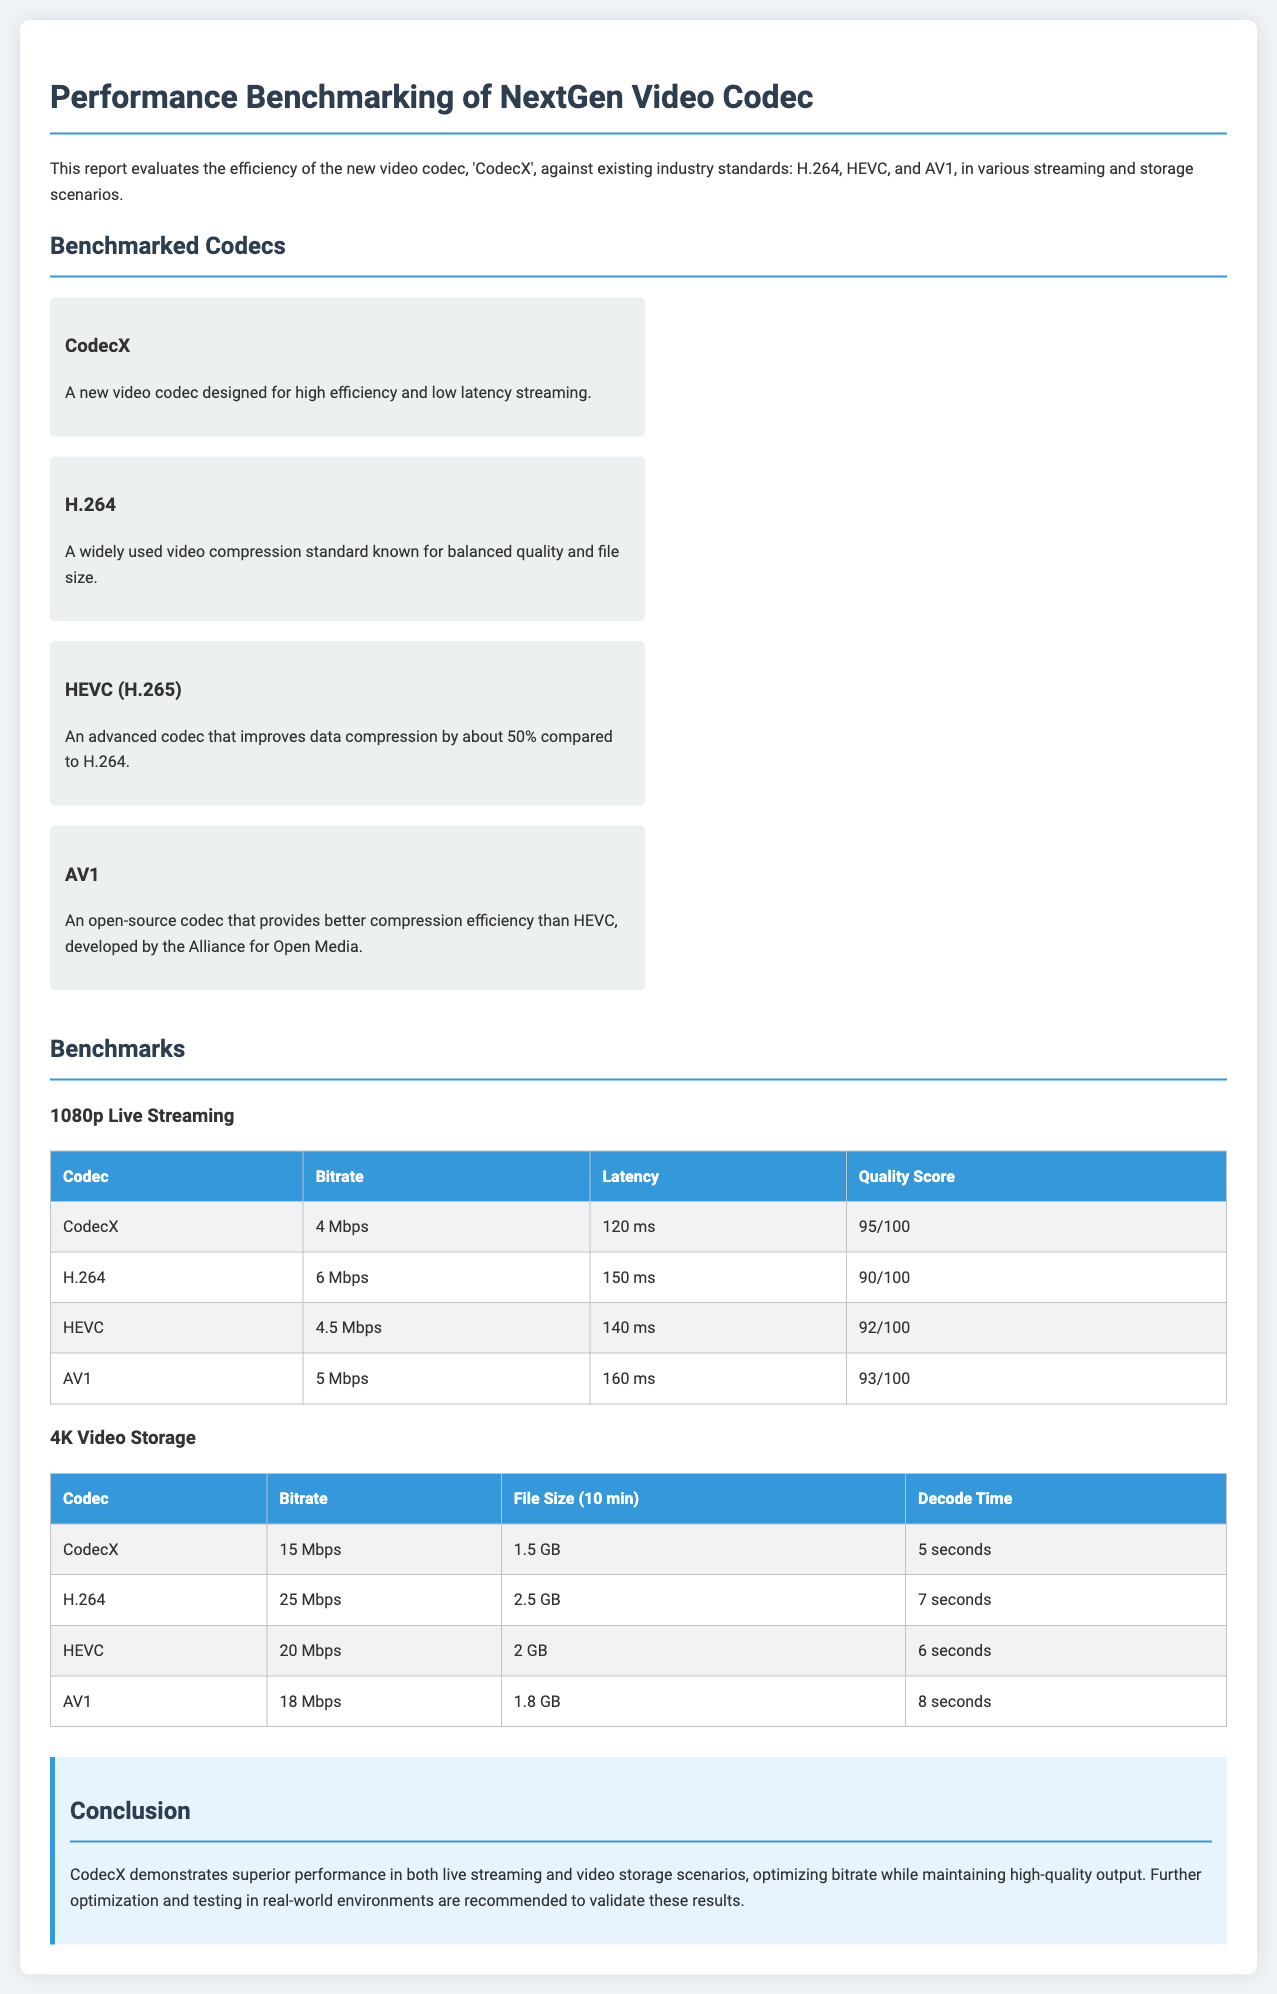What is the title of the report? The title of the report is prominently displayed at the top of the document.
Answer: Performance Benchmarking of NextGen Video Codec Which codec has the lowest bitrate in 1080p live streaming? The table provides the bitrate values for each codec in the specified scenario, highlighting CodecX as the lowest.
Answer: CodecX What is the quality score of H.264? The quality score for H.264 is explicitly mentioned in the benchmark table for live streaming.
Answer: 90/100 How long does it take to decode a 4K video using CodecX? The decode time is listed in the storage scenario table, specifically for CodecX.
Answer: 5 seconds Which codec has the highest file size for 10 minutes of 4K video? The table comparing file sizes indicates H.264 has the highest size among the listed codecs.
Answer: H.264 What is the latency of AV1 in 1080p live streaming? The latency is detailed in the live streaming benchmark table for AV1.
Answer: 160 ms Which codec outperforms others in both 1080p live streaming and 4K video storage? The conclusion summarizes that CodecX has demonstrated superior performance in both scenarios.
Answer: CodecX What does the report recommend for CodecX? The conclusion section suggests further actions or recommendations based on the findings presented in the report.
Answer: Further optimization and testing 